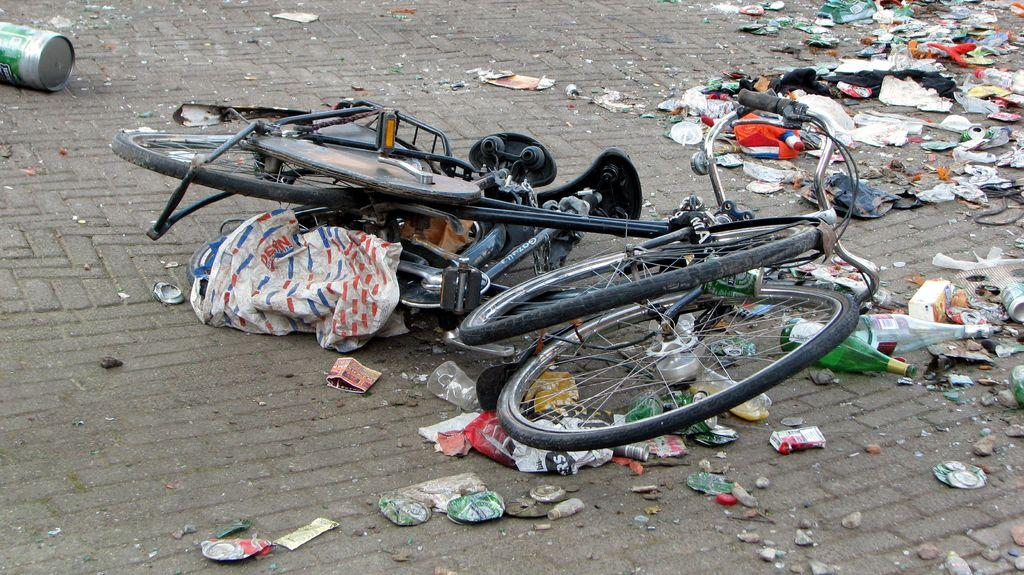What is the main object in the image? There is a bicycle in the image. What can be seen on the surface in the image? There is scrap on the surface in the image. What type of jeans is the bicycle wearing in the image? Bicycles do not wear jeans, as they are inanimate objects. 